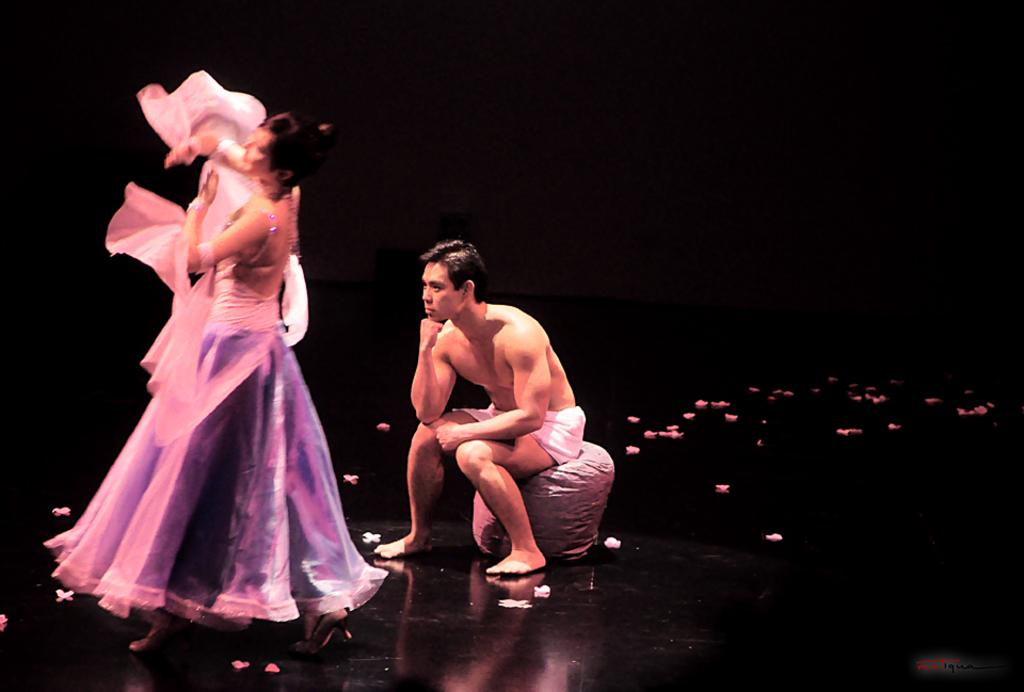How many people are on the stage in the image? There are two people on the stage in the image. What can be observed about the lighting in the image? The background of the image is dark. What type of destruction can be seen in the image caused by the wind? There is no wind or destruction present in the image; it features two people on a stage with a dark background. How many fingers does the person on the left have in the image? The number of fingers on the person's hand cannot be determined from the image, as their hands are not visible. 